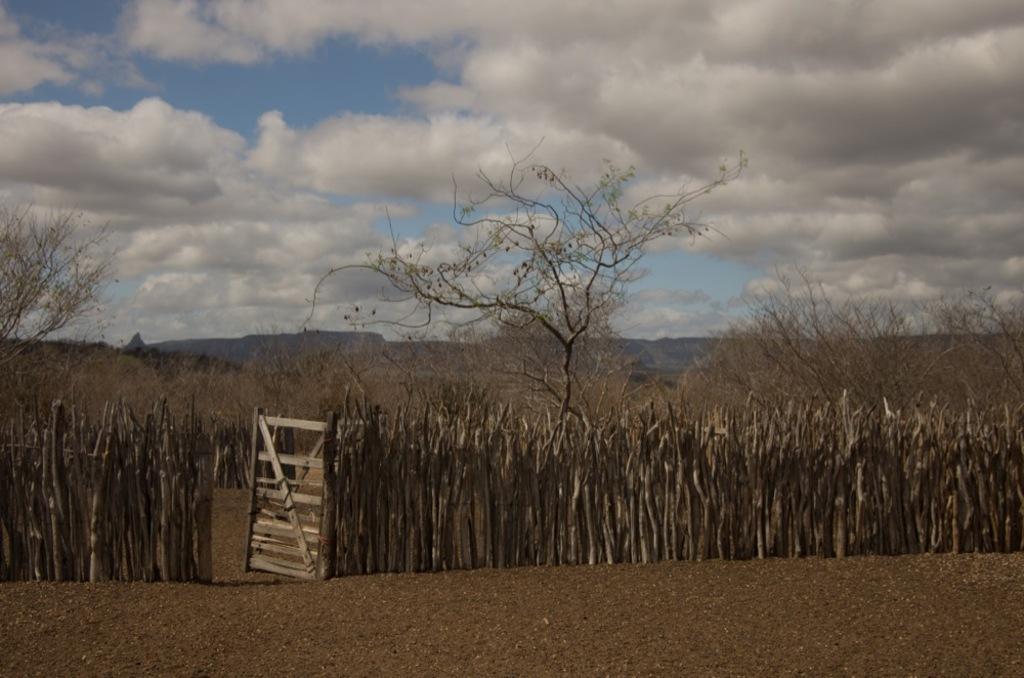Please provide a concise description of this image. In this image there is a wooden door with wooden stick fencing, inside the wooden fencing there are dry trees, in the background of the image there are mountains. 